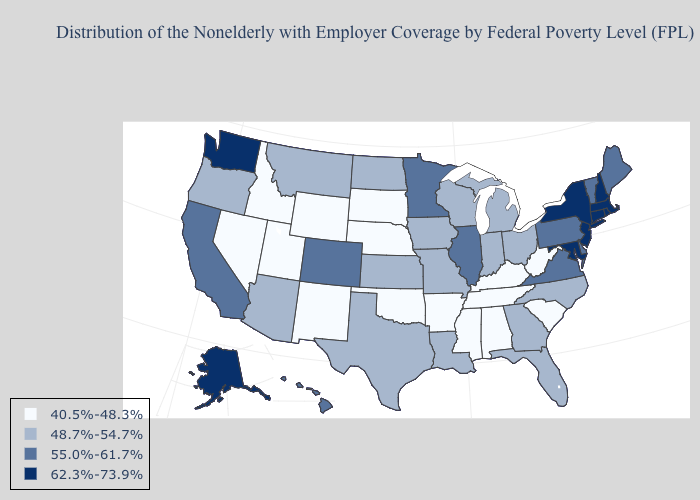Name the states that have a value in the range 48.7%-54.7%?
Give a very brief answer. Arizona, Florida, Georgia, Indiana, Iowa, Kansas, Louisiana, Michigan, Missouri, Montana, North Carolina, North Dakota, Ohio, Oregon, Texas, Wisconsin. What is the highest value in the West ?
Keep it brief. 62.3%-73.9%. Does Rhode Island have a lower value than Maine?
Quick response, please. No. What is the highest value in states that border Maryland?
Keep it brief. 55.0%-61.7%. Which states have the highest value in the USA?
Quick response, please. Alaska, Connecticut, Maryland, Massachusetts, New Hampshire, New Jersey, New York, Rhode Island, Washington. Does Mississippi have the lowest value in the USA?
Answer briefly. Yes. Name the states that have a value in the range 40.5%-48.3%?
Keep it brief. Alabama, Arkansas, Idaho, Kentucky, Mississippi, Nebraska, Nevada, New Mexico, Oklahoma, South Carolina, South Dakota, Tennessee, Utah, West Virginia, Wyoming. What is the value of North Carolina?
Short answer required. 48.7%-54.7%. Which states have the lowest value in the MidWest?
Short answer required. Nebraska, South Dakota. What is the highest value in the USA?
Concise answer only. 62.3%-73.9%. Name the states that have a value in the range 40.5%-48.3%?
Be succinct. Alabama, Arkansas, Idaho, Kentucky, Mississippi, Nebraska, Nevada, New Mexico, Oklahoma, South Carolina, South Dakota, Tennessee, Utah, West Virginia, Wyoming. What is the highest value in the USA?
Keep it brief. 62.3%-73.9%. What is the lowest value in states that border Illinois?
Concise answer only. 40.5%-48.3%. What is the highest value in states that border Colorado?
Write a very short answer. 48.7%-54.7%. What is the highest value in states that border Connecticut?
Keep it brief. 62.3%-73.9%. 